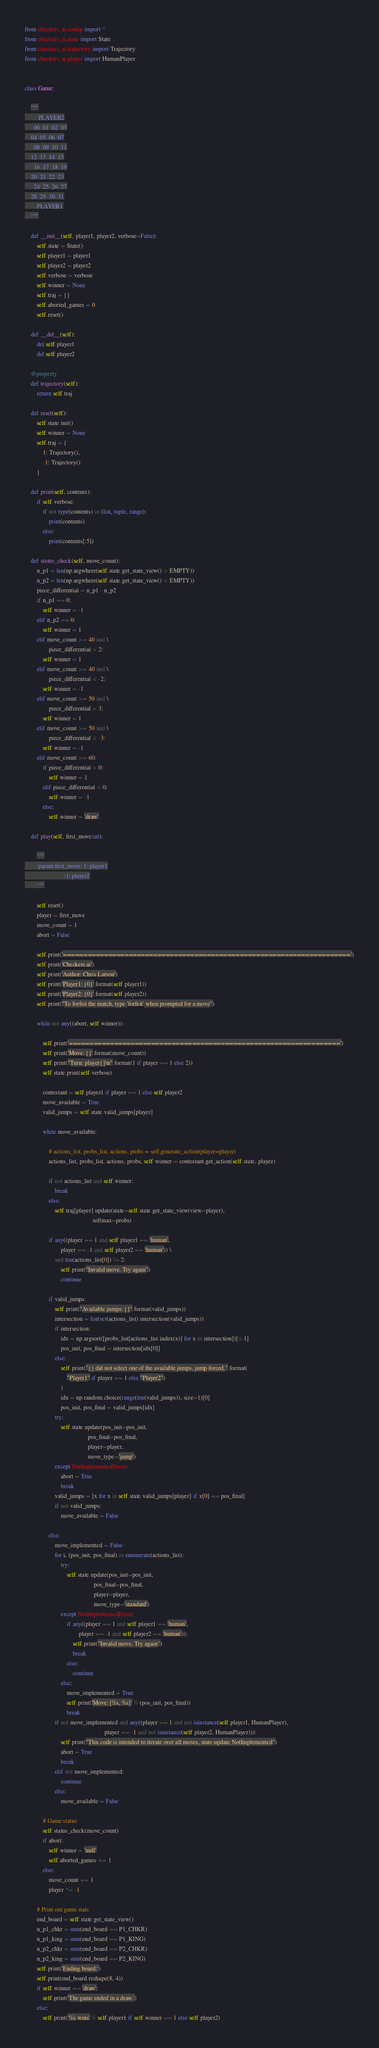<code> <loc_0><loc_0><loc_500><loc_500><_Python_>from checkers_ai.config import *
from checkers_ai.state import State
from checkers_ai.trajectory import Trajectory
from checkers_ai.player import HumanPlayer


class Game:

    """
         PLAYER2
      00  01  02  03
    04  05  06  07
      08  09  10  11
    12  13  14  15
      16  17  18  19
    20  21  22  23
      24  25  26  27
    28  29  30  31
        PLAYER1
    """

    def __init__(self, player1, player2, verbose=False):
        self.state = State()
        self.player1 = player1
        self.player2 = player2
        self.verbose = verbose
        self.winner = None
        self.traj = {}
        self.aborted_games = 0
        self.reset()

    def __del__(self):
        del self.player1
        del self.player2

    @property
    def trajectory(self):
        return self.traj

    def reset(self):
        self.state.init()
        self.winner = None
        self.traj = {
            1: Trajectory(),
            -1: Trajectory()
        }

    def print(self, contents):
        if self.verbose:
            if not type(contents) in (list, tuple, range):
                print(contents)
            else:
                print(contents[:5])

    def status_check(self, move_count):
        n_p1 = len(np.argwhere(self.state.get_state_view() > EMPTY))
        n_p2 = len(np.argwhere(self.state.get_state_view() < EMPTY))
        piece_differential = n_p1 - n_p2
        if n_p1 == 0:
            self.winner = -1
        elif n_p2 == 0:
            self.winner = 1
        elif move_count >= 40 and \
                piece_differential > 2:
            self.winner = 1
        elif move_count >= 40 and \
                piece_differential < -2:
            self.winner = -1
        elif move_count >= 50 and \
                piece_differential > 3:
            self.winner = 1
        elif move_count >= 50 and \
                piece_differential < -3:
            self.winner = -1
        elif move_count >= 60:
            if piece_differential > 0:
                self.winner = 1
            elif piece_differential < 0:
                self.winner = -1
            else:
                self.winner = 'draw'

    def play(self, first_move:int):

        """
        :param first_move: 1: player1
                          -1: player2
        """

        self.reset()
        player = first_move
        move_count = 1
        abort = False

        self.print('======================================================================')
        self.print('Checkers.ai')
        self.print('Author: Chris Larson')
        self.print('Player1: {0}'.format(self.player1))
        self.print('Player2: {0}'.format(self.player2))
        self.print("To forfeit the match, type 'forfeit' when prompted for a move")

        while not any((abort, self.winner)):

            self.print('==================================================================')
            self.print('Move: {}'.format(move_count))
            self.print("Turn: player{}\n".format(1 if player == 1 else 2))
            self.state.print(self.verbose)

            contestant = self.player1 if player == 1 else self.player2
            move_available = True
            valid_jumps = self.state.valid_jumps[player]

            while move_available:

                # actions_list, probs_list, actions, probs = self.generate_action(player=player)
                actions_list, probs_list, actions, probs, self.winner = contestant.get_action(self.state, player)

                if not actions_list and self.winner:
                    break
                else:
                    self.traj[player].update(state=self.state.get_state_view(view=player),
                                             softmax=probs)

                if any((player == 1 and self.player1 == 'human',
                        player == -1 and self.player2 == 'human')) \
                    and len(actions_list[0]) != 2:
                        self.print("Invalid move. Try again")
                        continue

                if valid_jumps:
                    self.print("Available jumps: {}".format(valid_jumps))
                    intersection = list(set(actions_list).intersection(valid_jumps))
                    if intersection:
                        idx = np.argsort([probs_list[actions_list.index(x)] for x in intersection])[::-1]
                        pos_init, pos_final = intersection[idx[0]]
                    else:
                        self.print("{} did not select one of the available jumps, jump forced.".format(
                            "Player1" if player == 1 else "Player2")
                        )
                        idx = np.random.choice(range(len(valid_jumps)), size=1)[0]
                        pos_init, pos_final = valid_jumps[idx]
                    try:
                        self.state.update(pos_init=pos_init,
                                          pos_final=pos_final,
                                          player=player,
                                          move_type='jump')
                    except NotImplementedError:
                        abort = True
                        break
                    valid_jumps = [x for x in self.state.valid_jumps[player] if x[0] == pos_final]
                    if not valid_jumps:
                        move_available = False

                else:
                    move_implemented = False
                    for i, (pos_init, pos_final) in enumerate(actions_list):
                        try:
                            self.state.update(pos_init=pos_init,
                                              pos_final=pos_final,
                                              player=player,
                                              move_type='standard')
                        except NotImplementedError:
                            if any((player == 1 and self.player1 == 'human',
                                    player == -1 and self.player2 == 'human')):
                                self.print("Invalid move. Try again")
                                break
                            else:
                                continue
                        else:
                            move_implemented = True
                            self.print('Move: [%s, %s]' % (pos_init, pos_final))
                            break
                    if not move_implemented and any((player == 1 and not isinstance(self.player1, HumanPlayer),
                                                     player == -1 and not isinstance(self.player2, HumanPlayer))):
                        self.print("This code is intended to iterate over all moves, state-update NotImplemented")
                        abort = True
                        break
                    elif not move_implemented:
                        continue
                    else:
                        move_available = False

            # Game status
            self.status_check(move_count)
            if abort:
                self.winner = 'null'
                self.aborted_games += 1
            else:
                move_count += 1
                player *= -1

        # Print out game stats
        end_board = self.state.get_state_view()
        n_p1_chkr = sum(end_board == P1_CHKR)
        n_p1_king = sum(end_board == P1_KING)
        n_p2_chkr = sum(end_board == P2_CHKR)
        n_p2_king = sum(end_board == P2_KING)
        self.print('Ending board:')
        self.print(end_board.reshape(8, 4))
        if self.winner == 'draw':
            self.print('The game ended in a draw.')
        else:
            self.print('%s wins' % self.player1 if self.winner == 1 else self.player2)</code> 